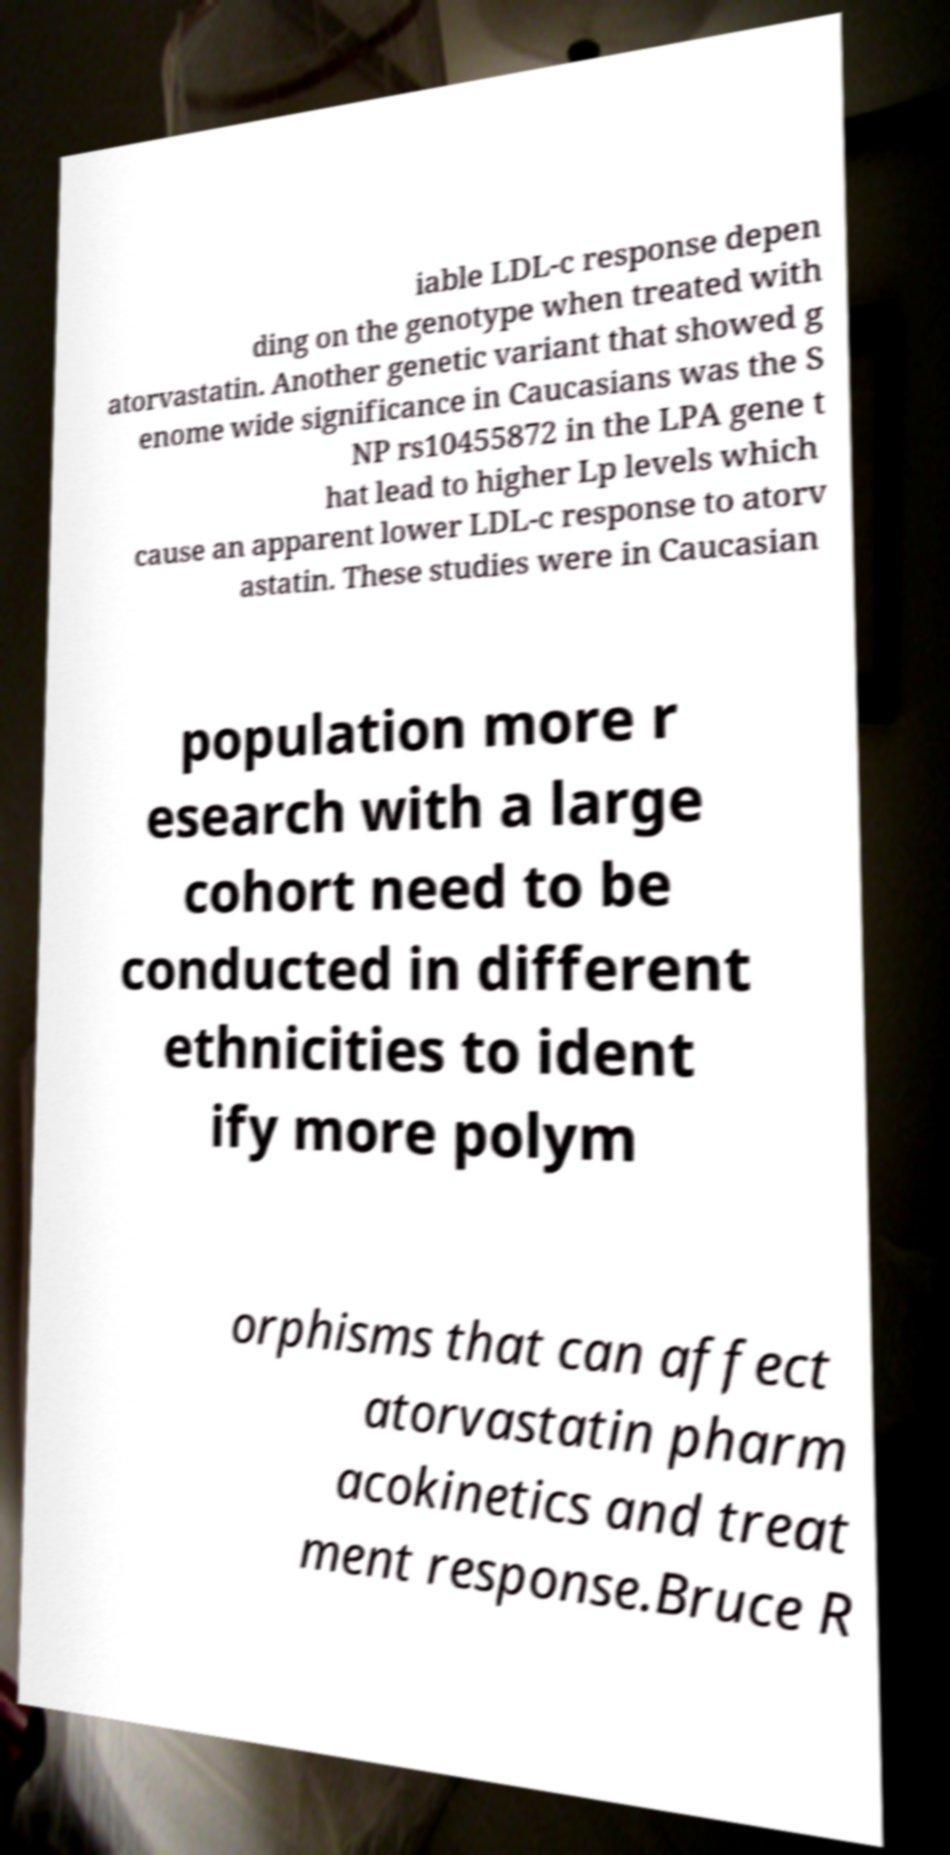There's text embedded in this image that I need extracted. Can you transcribe it verbatim? iable LDL-c response depen ding on the genotype when treated with atorvastatin. Another genetic variant that showed g enome wide significance in Caucasians was the S NP rs10455872 in the LPA gene t hat lead to higher Lp levels which cause an apparent lower LDL-c response to atorv astatin. These studies were in Caucasian population more r esearch with a large cohort need to be conducted in different ethnicities to ident ify more polym orphisms that can affect atorvastatin pharm acokinetics and treat ment response.Bruce R 